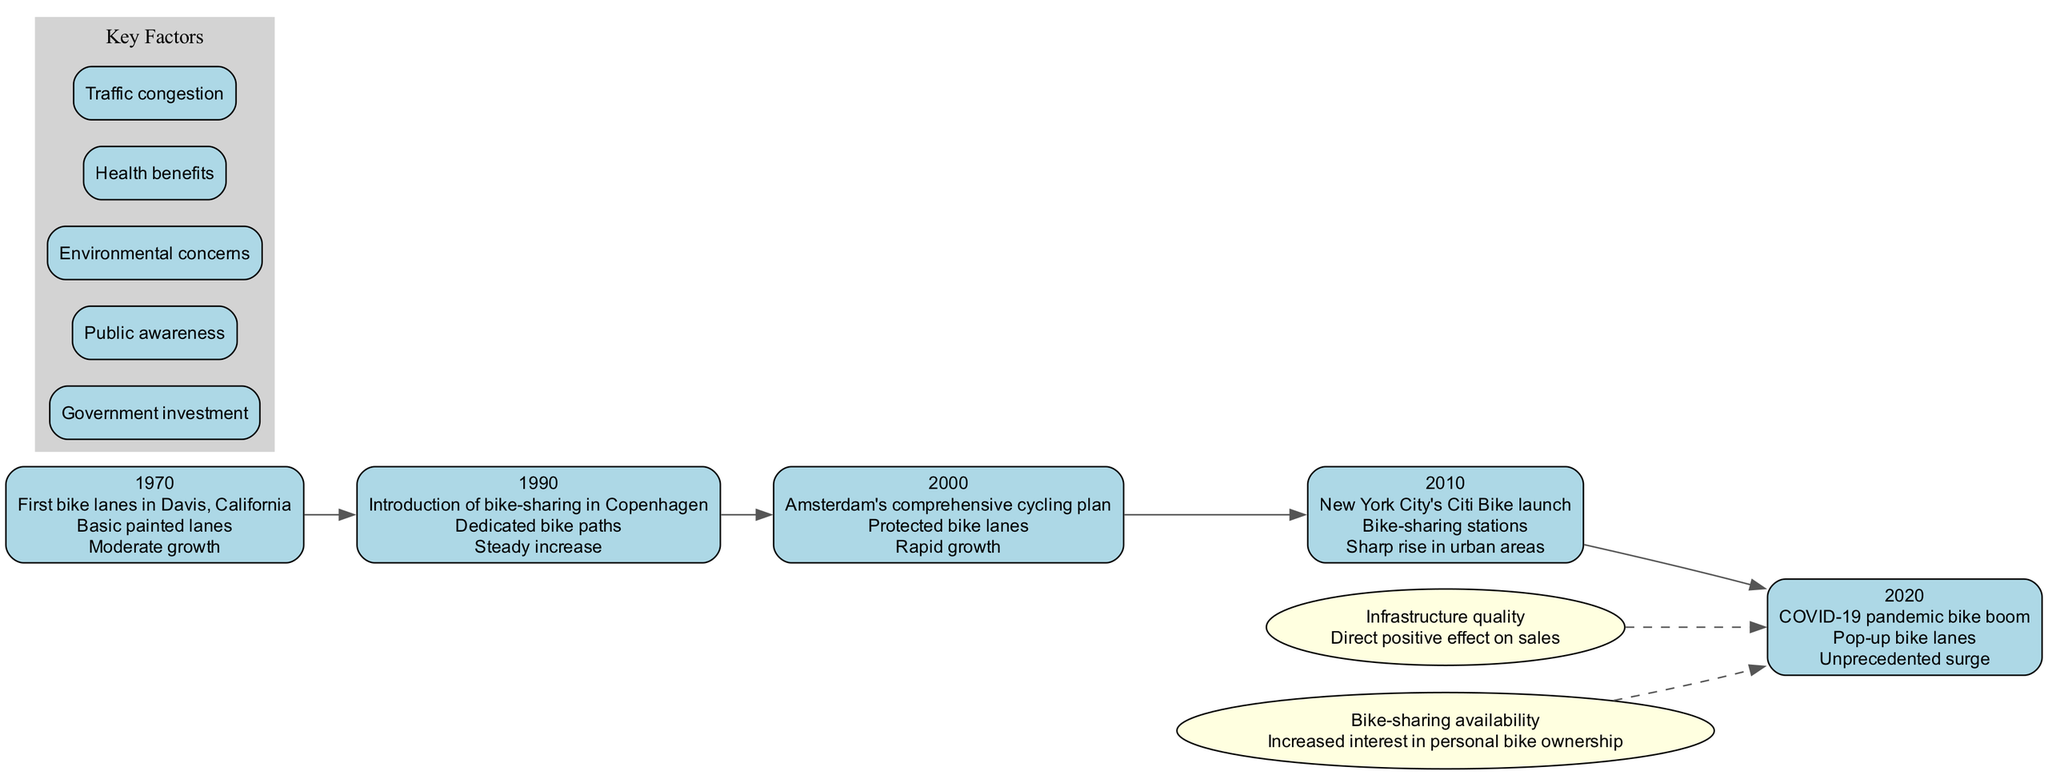What year did the COVID-19 pandemic bike boom occur? The diagram lists the timeline events by year, and the entry for the COVID-19 pandemic bike boom is labeled with the year 2020.
Answer: 2020 What type of infrastructure was introduced in 1990 in Copenhagen? By examining the node corresponding to 1990, it indicates that the infrastructure introduced in that year was "Dedicated bike paths."
Answer: Dedicated bike paths How many key factors are identified in the diagram? The diagram features a subgraph labeled "Key Factors," which contains a total of five distinct factors listed within it.
Answer: 5 What was the sales trend in the year 2000? Looking at the node for the year 2000, the sales trend indicated is "Rapid growth."
Answer: Rapid growth What is the direct impact of infrastructure quality on bicycle sales? The correlation listed for "Infrastructure quality" states that it has a "Direct positive effect on sales," highlighting the favorable impact on sales figures.
Answer: Direct positive effect on sales Which event had the most significant sales trend? The 2020 event, described as the "COVID-19 pandemic bike boom," is marked with "Unprecedented surge," indicating it had the most significant increase in sales.
Answer: Unprecedented surge What event marked the start of bike-sharing in North America? The launch of "New York City's Citi Bike" in the year 2010 is highlighted, representing the beginning of bike-sharing in urban areas of North America as per the timeline.
Answer: New York City's Citi Bike launch How did the introduction of bike-sharing affect personal bike ownership? According to the correlation related to "Bike-sharing availability," it states that it led to "Increased interest in personal bike ownership."
Answer: Increased interest in personal bike ownership What infrastructure was introduced in 2000? The node for the year 2000 specifies that the infrastructure implemented was "Protected bike lanes."
Answer: Protected bike lanes 